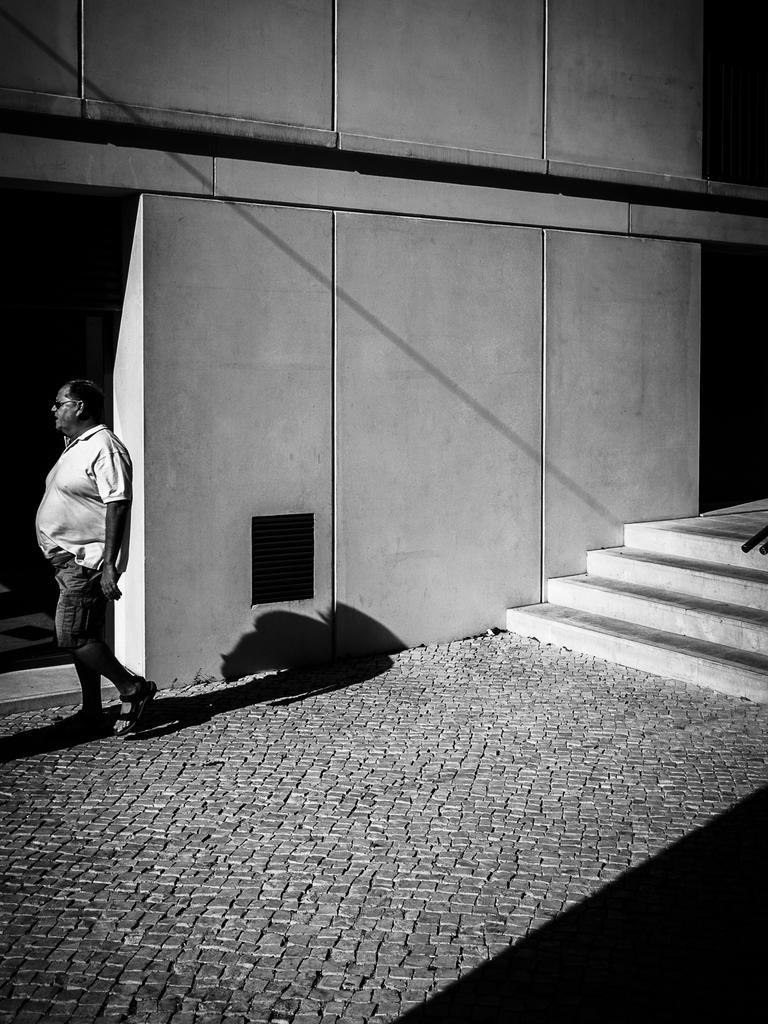What type of structure is present in the image? There is a building in the image. What architectural feature is visible in the image? There are stairs in the image. Can you describe the man in the image? The man in the image is wearing a white color shirt. What type of cart does the man use to transport his carpentry tools in the image? There is no cart or carpentry tools present in the image. What is the man's desire in the image? The image does not provide information about the man's desires or thoughts. 